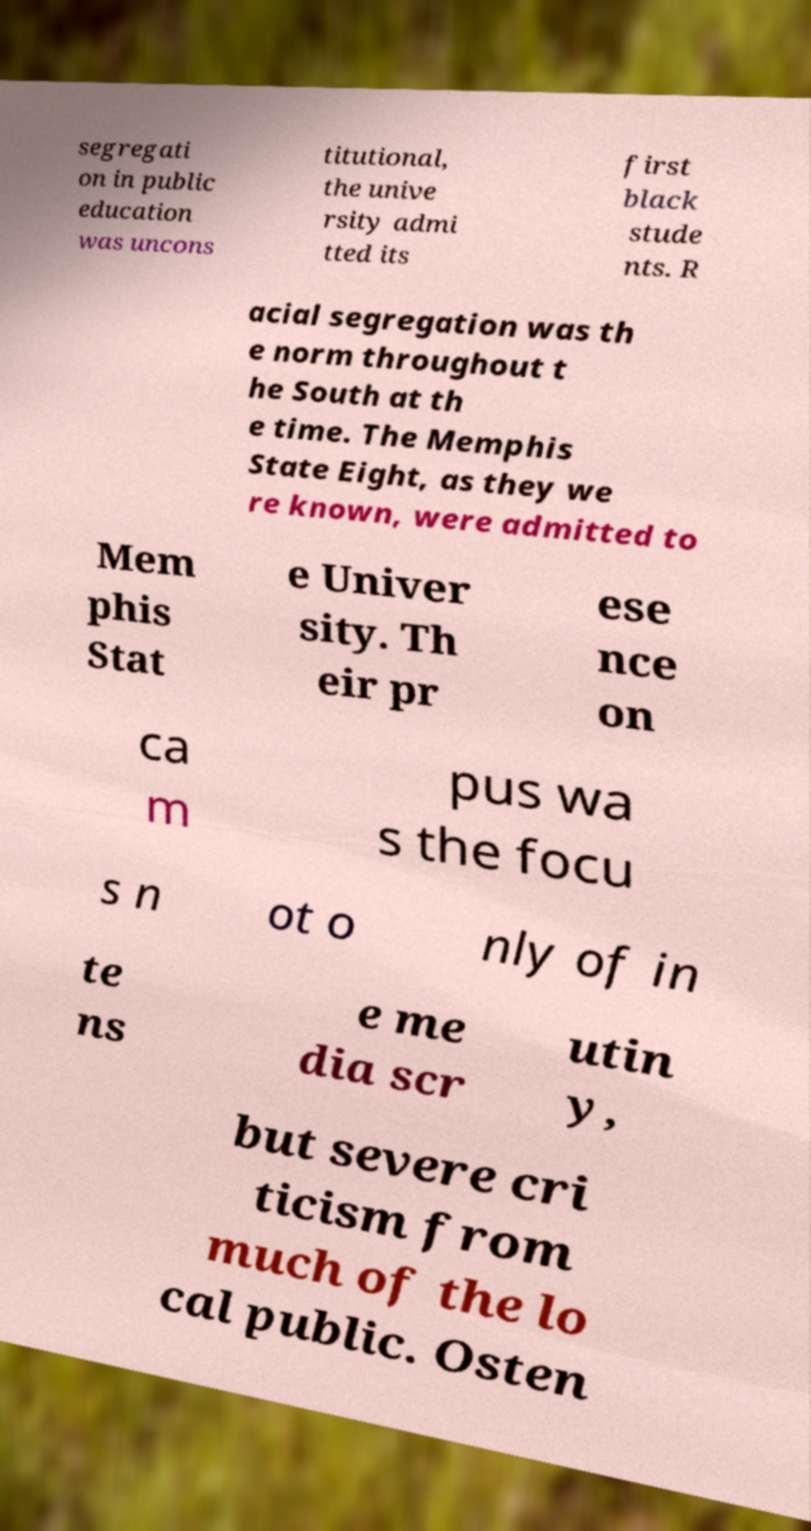Could you assist in decoding the text presented in this image and type it out clearly? segregati on in public education was uncons titutional, the unive rsity admi tted its first black stude nts. R acial segregation was th e norm throughout t he South at th e time. The Memphis State Eight, as they we re known, were admitted to Mem phis Stat e Univer sity. Th eir pr ese nce on ca m pus wa s the focu s n ot o nly of in te ns e me dia scr utin y, but severe cri ticism from much of the lo cal public. Osten 